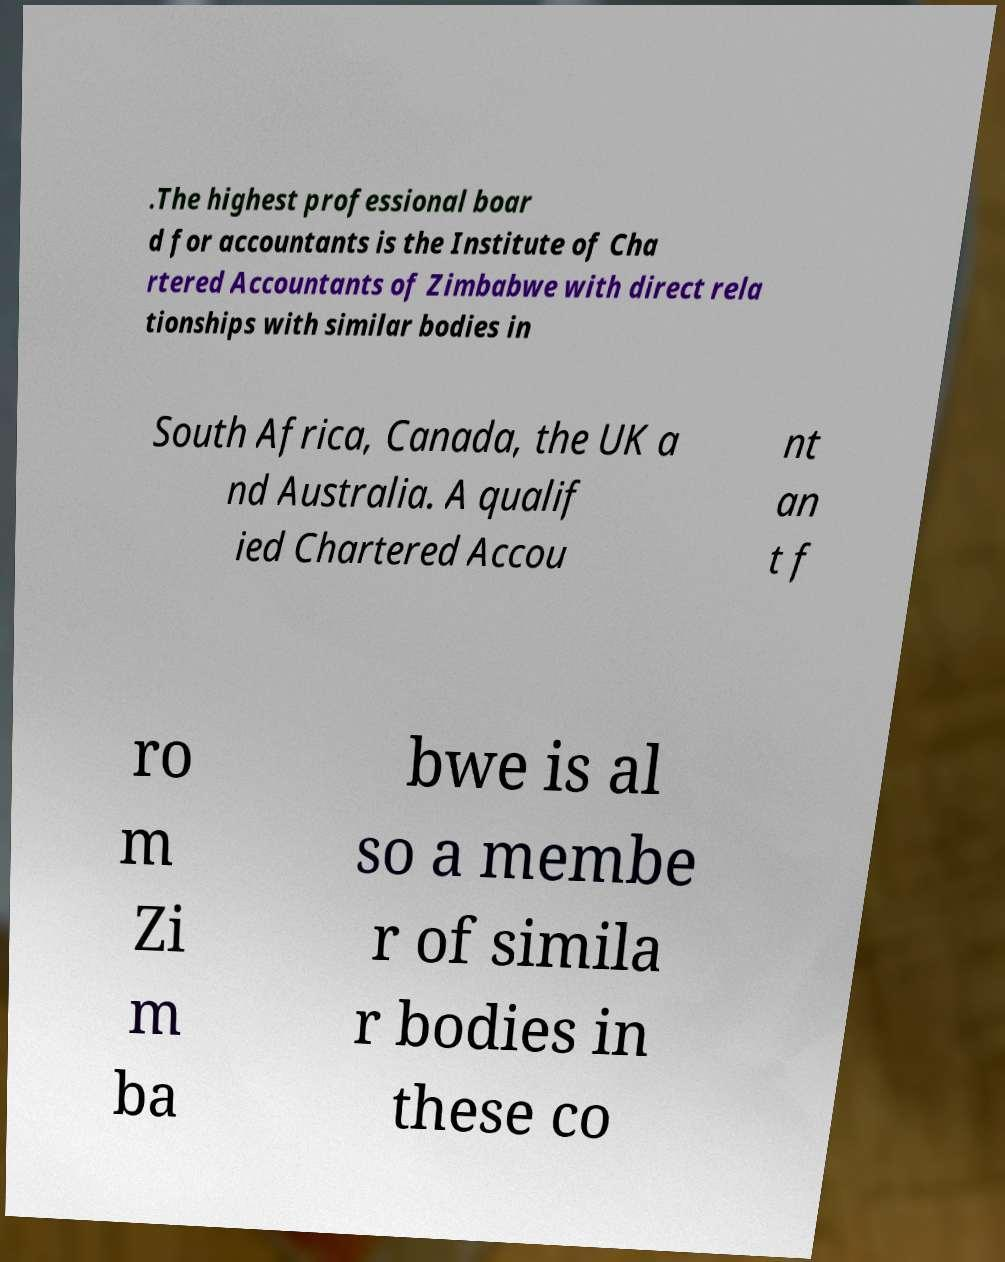There's text embedded in this image that I need extracted. Can you transcribe it verbatim? .The highest professional boar d for accountants is the Institute of Cha rtered Accountants of Zimbabwe with direct rela tionships with similar bodies in South Africa, Canada, the UK a nd Australia. A qualif ied Chartered Accou nt an t f ro m Zi m ba bwe is al so a membe r of simila r bodies in these co 